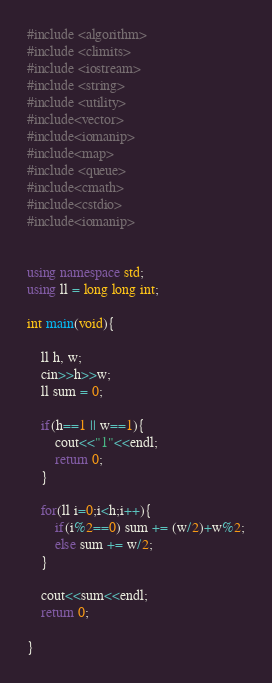<code> <loc_0><loc_0><loc_500><loc_500><_C++_>#include <algorithm>
#include <climits>
#include <iostream>
#include <string>
#include <utility>
#include<vector>
#include<iomanip>
#include<map>
#include <queue>
#include<cmath>
#include<cstdio>
#include<iomanip>


using namespace std;
using ll = long long int; 

int main(void){

    ll h, w;
    cin>>h>>w;
    ll sum = 0;

    if(h==1 || w==1){
        cout<<"1"<<endl;
        return 0;
    }

    for(ll i=0;i<h;i++){
        if(i%2==0) sum += (w/2)+w%2;
        else sum += w/2;
    }

    cout<<sum<<endl;
    return 0;

}</code> 